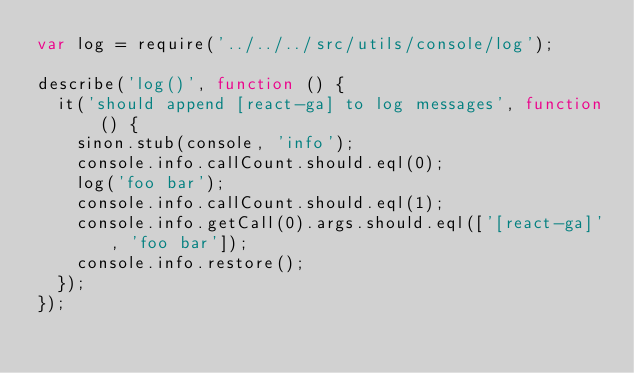Convert code to text. <code><loc_0><loc_0><loc_500><loc_500><_JavaScript_>var log = require('../../../src/utils/console/log');

describe('log()', function () {
  it('should append [react-ga] to log messages', function () {
    sinon.stub(console, 'info');
    console.info.callCount.should.eql(0);
    log('foo bar');
    console.info.callCount.should.eql(1);
    console.info.getCall(0).args.should.eql(['[react-ga]', 'foo bar']);
    console.info.restore();
  });
});
</code> 